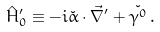<formula> <loc_0><loc_0><loc_500><loc_500>\hat { H } ^ { \prime } _ { 0 } \equiv - i \check { \alpha } \cdot \vec { \nabla } ^ { \prime } + \check { \gamma ^ { 0 } } \, .</formula> 